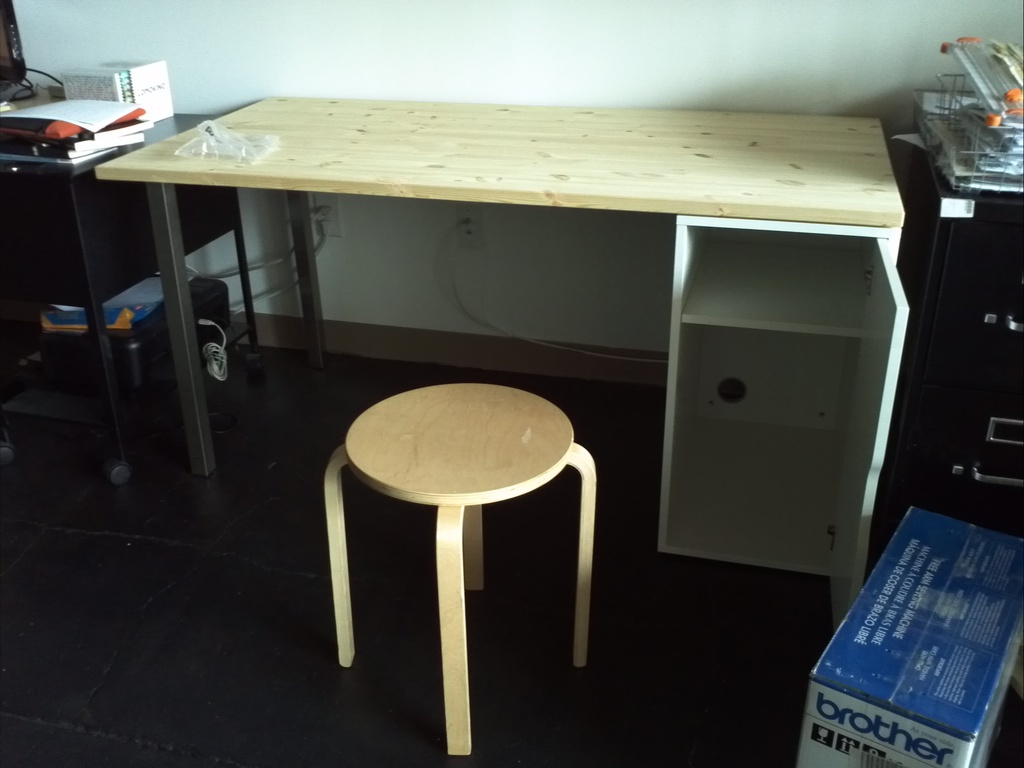Can you comment on the material and design aesthetics visible in the image? The furniture in the image showcases a modern, minimalist design using natural wood, which complements the industrial gray tones of the room's metallic elements and dark flooring, effectively blending rustic charm with a modern industrial look. How does the lighting affect the mood or functionality of the room? The ample natural light streaming through a window, not directly visible here, brightens the space and enhances functionality, making the room appear more welcoming while providing sufficient illumination for work-related tasks. 